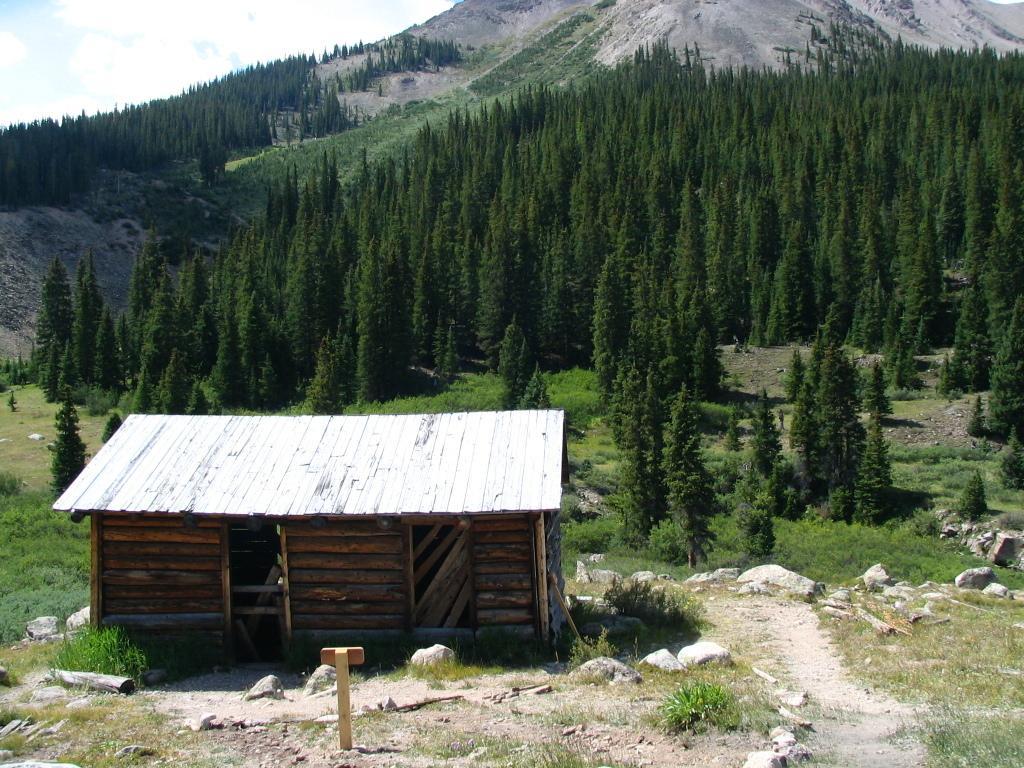In one or two sentences, can you explain what this image depicts? In the picture we can see a surface with some grass, rocks and plants and near to it, we can see some small wooden house and behind it, we can see trees and hills and grass on it and sky. 